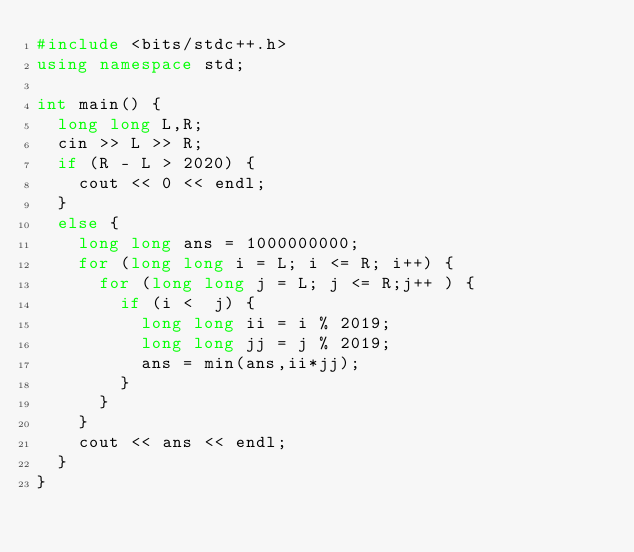<code> <loc_0><loc_0><loc_500><loc_500><_C++_>#include <bits/stdc++.h>
using namespace std;

int main() {
  long long L,R;
  cin >> L >> R;
  if (R - L > 2020) {
    cout << 0 << endl;
  }
  else {
    long long ans = 1000000000;
    for (long long i = L; i <= R; i++) {
      for (long long j = L; j <= R;j++ ) {
        if (i <  j) {
          long long ii = i % 2019;
          long long jj = j % 2019;
          ans = min(ans,ii*jj);
        }
      }
    }
    cout << ans << endl;
  }
}
</code> 